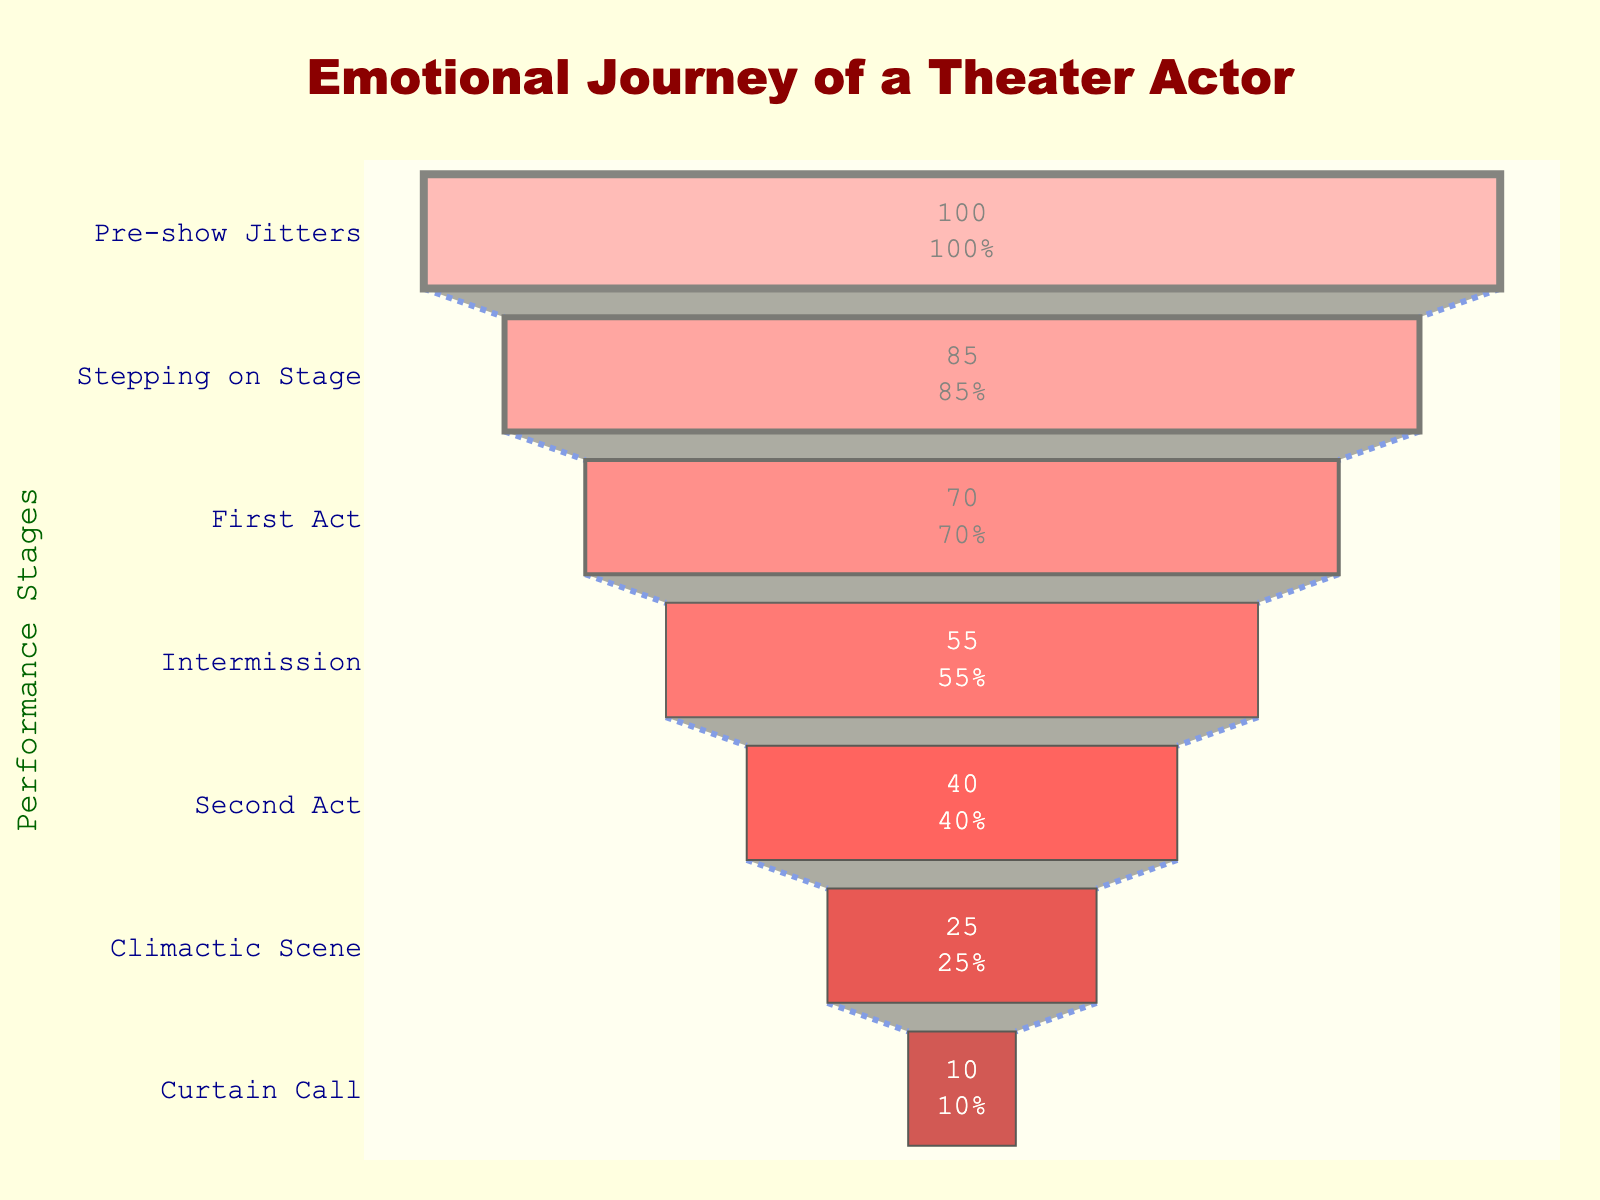What percentage of actors feel an "Adrenaline Rush" when stepping on stage? According to the Funnel Chart, the percentage of actors experiencing an "Adrenaline Rush" at the stage "Stepping on Stage" is directly provided.
Answer: 85% What is the title of the Funnel Chart? The title of the chart is clearly displayed at the top.
Answer: Emotional Journey of a Theater Actor Calculate the difference in the percentage of actors experiencing "Focused Intensity" (First Act) and "Reflective Calm" (Intermission). The Funnel Chart shows 70% of actors feel "Focused Intensity" during the First Act and 55% feel "Reflective Calm" during Intermission. The difference is 70% - 55%.
Answer: 15% Which stage has the lowest percentage of actors associated with it? The Funnel Chart shows that the "Curtain Call" stage has the smallest percentage of 10%.
Answer: Curtain Call How many different emotions are detailed in the chart? Each stage of the performance is linked to a unique emotion. Counting all the stages provides the total number of emotions.
Answer: 7 During which stage do actors shift from feeling "Nervous Anticipation" to "Adrenaline Rush"? The Funnel Chart shows actors transition from "Pre-show Jitters" with "Nervous Anticipation" to "Stepping on Stage" with "Adrenaline Rush."
Answer: Stepping on Stage Compare the percentage of actors experiencing "Raw Catharsis" during the Climactic Scene to those feeling "Exhilarated Relief" at the Curtain Call. The chart shows 25% of actors feel "Raw Catharsis" during the Climactic Scene, and only 10% feel "Exhilarated Relief" at the Curtain Call. Therefore, 25% is higher than 10%.
Answer: Higher at Climactic Scene Which stage represents a state where actors have a "Reflective Calm"? The Funnel Chart indicates that "Intermission" is the stage with "Reflective Calm."
Answer: Intermission Examine the transition between "Emotional Immersion" and "Raw Catharsis." What is the change in the percentage of actors? The Funnel Chart shifts from "Emotional Immersion" with 40% to "Raw Catharsis" with 25%, so the change is 40% - 25%.
Answer: 15% Determine the percentage by which "Focused Intensity" is greater than "Raw Catharsis." "Focused Intensity" (70%) from the First Act is greater than "Raw Catharsis" (25%) from the Climactic Scene. Calculating 70% - 25% gives the difference.
Answer: 45% 